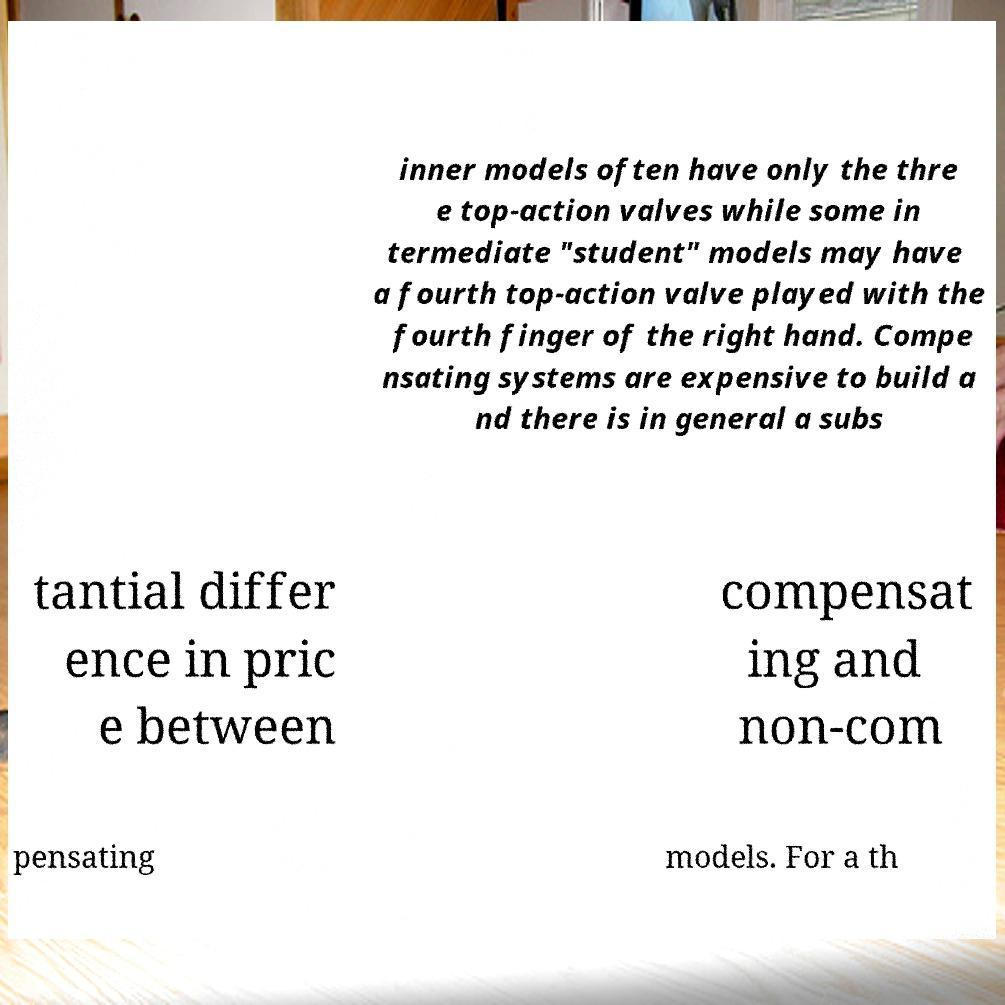What messages or text are displayed in this image? I need them in a readable, typed format. inner models often have only the thre e top-action valves while some in termediate "student" models may have a fourth top-action valve played with the fourth finger of the right hand. Compe nsating systems are expensive to build a nd there is in general a subs tantial differ ence in pric e between compensat ing and non-com pensating models. For a th 